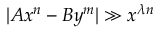Convert formula to latex. <formula><loc_0><loc_0><loc_500><loc_500>| A x ^ { n } - B y ^ { m } | \gg x ^ { \lambda n }</formula> 